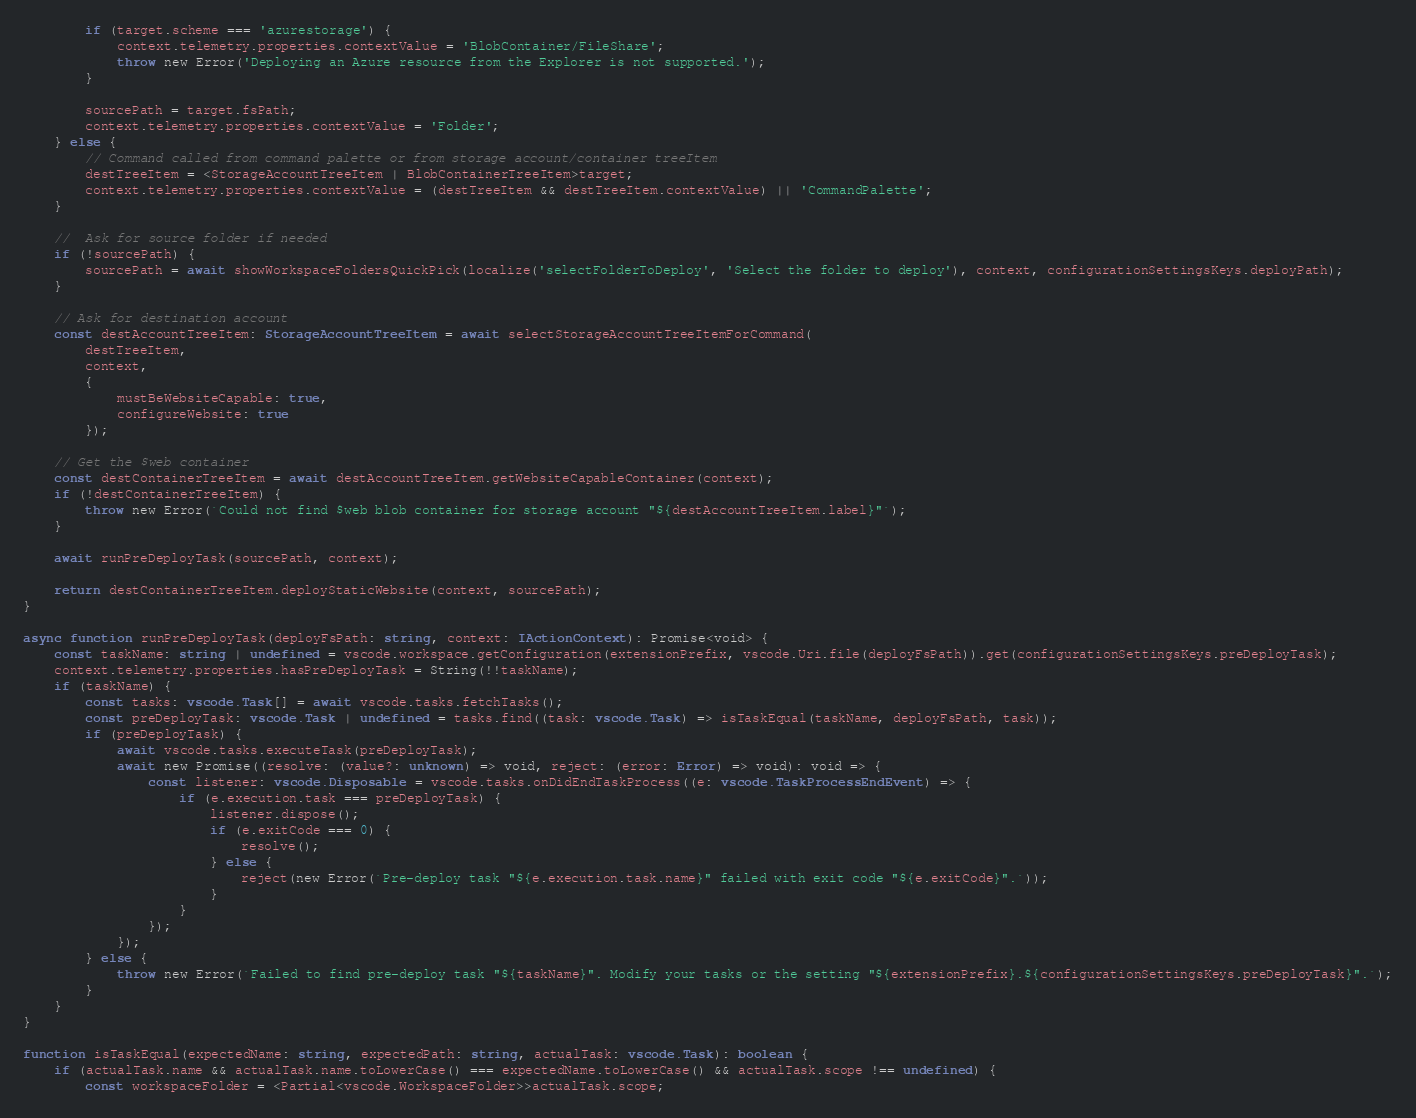<code> <loc_0><loc_0><loc_500><loc_500><_TypeScript_>        if (target.scheme === 'azurestorage') {
            context.telemetry.properties.contextValue = 'BlobContainer/FileShare';
            throw new Error('Deploying an Azure resource from the Explorer is not supported.');
        }

        sourcePath = target.fsPath;
        context.telemetry.properties.contextValue = 'Folder';
    } else {
        // Command called from command palette or from storage account/container treeItem
        destTreeItem = <StorageAccountTreeItem | BlobContainerTreeItem>target;
        context.telemetry.properties.contextValue = (destTreeItem && destTreeItem.contextValue) || 'CommandPalette';
    }

    //  Ask for source folder if needed
    if (!sourcePath) {
        sourcePath = await showWorkspaceFoldersQuickPick(localize('selectFolderToDeploy', 'Select the folder to deploy'), context, configurationSettingsKeys.deployPath);
    }

    // Ask for destination account
    const destAccountTreeItem: StorageAccountTreeItem = await selectStorageAccountTreeItemForCommand(
        destTreeItem,
        context,
        {
            mustBeWebsiteCapable: true,
            configureWebsite: true
        });

    // Get the $web container
    const destContainerTreeItem = await destAccountTreeItem.getWebsiteCapableContainer(context);
    if (!destContainerTreeItem) {
        throw new Error(`Could not find $web blob container for storage account "${destAccountTreeItem.label}"`);
    }

    await runPreDeployTask(sourcePath, context);

    return destContainerTreeItem.deployStaticWebsite(context, sourcePath);
}

async function runPreDeployTask(deployFsPath: string, context: IActionContext): Promise<void> {
    const taskName: string | undefined = vscode.workspace.getConfiguration(extensionPrefix, vscode.Uri.file(deployFsPath)).get(configurationSettingsKeys.preDeployTask);
    context.telemetry.properties.hasPreDeployTask = String(!!taskName);
    if (taskName) {
        const tasks: vscode.Task[] = await vscode.tasks.fetchTasks();
        const preDeployTask: vscode.Task | undefined = tasks.find((task: vscode.Task) => isTaskEqual(taskName, deployFsPath, task));
        if (preDeployTask) {
            await vscode.tasks.executeTask(preDeployTask);
            await new Promise((resolve: (value?: unknown) => void, reject: (error: Error) => void): void => {
                const listener: vscode.Disposable = vscode.tasks.onDidEndTaskProcess((e: vscode.TaskProcessEndEvent) => {
                    if (e.execution.task === preDeployTask) {
                        listener.dispose();
                        if (e.exitCode === 0) {
                            resolve();
                        } else {
                            reject(new Error(`Pre-deploy task "${e.execution.task.name}" failed with exit code "${e.exitCode}".`));
                        }
                    }
                });
            });
        } else {
            throw new Error(`Failed to find pre-deploy task "${taskName}". Modify your tasks or the setting "${extensionPrefix}.${configurationSettingsKeys.preDeployTask}".`);
        }
    }
}

function isTaskEqual(expectedName: string, expectedPath: string, actualTask: vscode.Task): boolean {
    if (actualTask.name && actualTask.name.toLowerCase() === expectedName.toLowerCase() && actualTask.scope !== undefined) {
        const workspaceFolder = <Partial<vscode.WorkspaceFolder>>actualTask.scope;</code> 